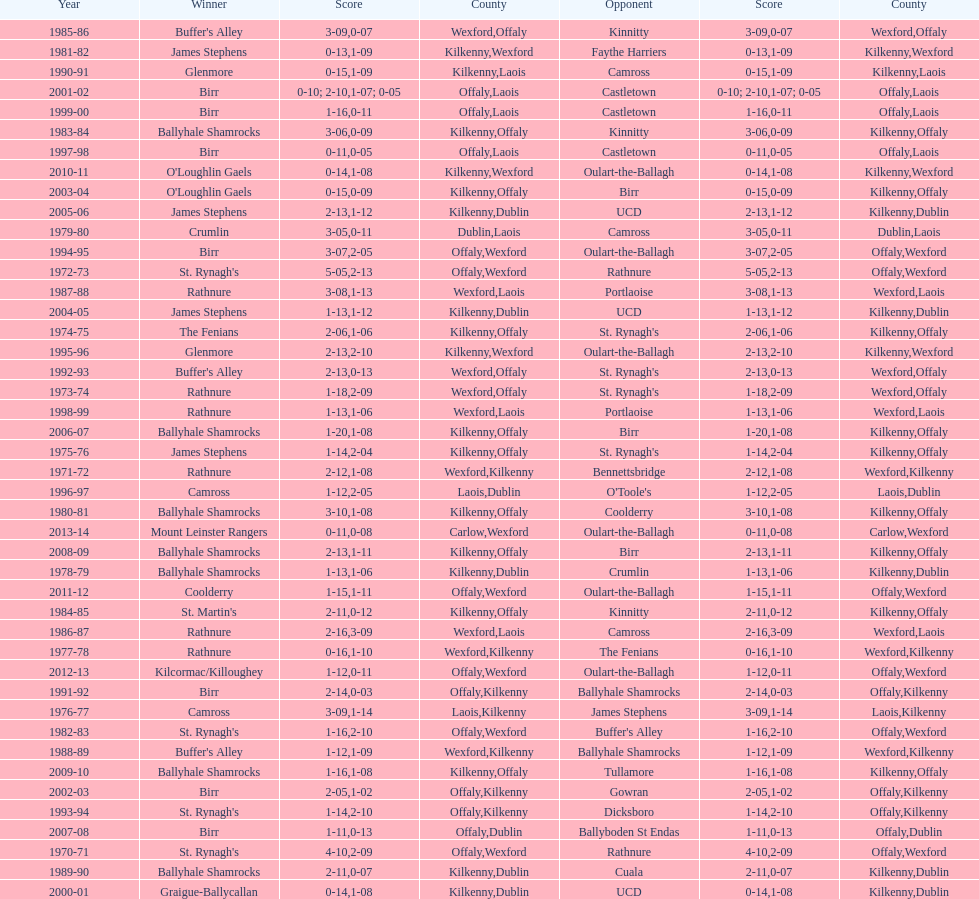Help me parse the entirety of this table. {'header': ['Year', 'Winner', 'Score', 'County', 'Opponent', 'Score', 'County'], 'rows': [['1985-86', "Buffer's Alley", '3-09', 'Wexford', 'Kinnitty', '0-07', 'Offaly'], ['1981-82', 'James Stephens', '0-13', 'Kilkenny', 'Faythe Harriers', '1-09', 'Wexford'], ['1990-91', 'Glenmore', '0-15', 'Kilkenny', 'Camross', '1-09', 'Laois'], ['2001-02', 'Birr', '0-10; 2-10', 'Offaly', 'Castletown', '1-07; 0-05', 'Laois'], ['1999-00', 'Birr', '1-16', 'Offaly', 'Castletown', '0-11', 'Laois'], ['1983-84', 'Ballyhale Shamrocks', '3-06', 'Kilkenny', 'Kinnitty', '0-09', 'Offaly'], ['1997-98', 'Birr', '0-11', 'Offaly', 'Castletown', '0-05', 'Laois'], ['2010-11', "O'Loughlin Gaels", '0-14', 'Kilkenny', 'Oulart-the-Ballagh', '1-08', 'Wexford'], ['2003-04', "O'Loughlin Gaels", '0-15', 'Kilkenny', 'Birr', '0-09', 'Offaly'], ['2005-06', 'James Stephens', '2-13', 'Kilkenny', 'UCD', '1-12', 'Dublin'], ['1979-80', 'Crumlin', '3-05', 'Dublin', 'Camross', '0-11', 'Laois'], ['1994-95', 'Birr', '3-07', 'Offaly', 'Oulart-the-Ballagh', '2-05', 'Wexford'], ['1972-73', "St. Rynagh's", '5-05', 'Offaly', 'Rathnure', '2-13', 'Wexford'], ['1987-88', 'Rathnure', '3-08', 'Wexford', 'Portlaoise', '1-13', 'Laois'], ['2004-05', 'James Stephens', '1-13', 'Kilkenny', 'UCD', '1-12', 'Dublin'], ['1974-75', 'The Fenians', '2-06', 'Kilkenny', "St. Rynagh's", '1-06', 'Offaly'], ['1995-96', 'Glenmore', '2-13', 'Kilkenny', 'Oulart-the-Ballagh', '2-10', 'Wexford'], ['1992-93', "Buffer's Alley", '2-13', 'Wexford', "St. Rynagh's", '0-13', 'Offaly'], ['1973-74', 'Rathnure', '1-18', 'Wexford', "St. Rynagh's", '2-09', 'Offaly'], ['1998-99', 'Rathnure', '1-13', 'Wexford', 'Portlaoise', '1-06', 'Laois'], ['2006-07', 'Ballyhale Shamrocks', '1-20', 'Kilkenny', 'Birr', '1-08', 'Offaly'], ['1975-76', 'James Stephens', '1-14', 'Kilkenny', "St. Rynagh's", '2-04', 'Offaly'], ['1971-72', 'Rathnure', '2-12', 'Wexford', 'Bennettsbridge', '1-08', 'Kilkenny'], ['1996-97', 'Camross', '1-12', 'Laois', "O'Toole's", '2-05', 'Dublin'], ['1980-81', 'Ballyhale Shamrocks', '3-10', 'Kilkenny', 'Coolderry', '1-08', 'Offaly'], ['2013-14', 'Mount Leinster Rangers', '0-11', 'Carlow', 'Oulart-the-Ballagh', '0-08', 'Wexford'], ['2008-09', 'Ballyhale Shamrocks', '2-13', 'Kilkenny', 'Birr', '1-11', 'Offaly'], ['1978-79', 'Ballyhale Shamrocks', '1-13', 'Kilkenny', 'Crumlin', '1-06', 'Dublin'], ['2011-12', 'Coolderry', '1-15', 'Offaly', 'Oulart-the-Ballagh', '1-11', 'Wexford'], ['1984-85', "St. Martin's", '2-11', 'Kilkenny', 'Kinnitty', '0-12', 'Offaly'], ['1986-87', 'Rathnure', '2-16', 'Wexford', 'Camross', '3-09', 'Laois'], ['1977-78', 'Rathnure', '0-16', 'Wexford', 'The Fenians', '1-10', 'Kilkenny'], ['2012-13', 'Kilcormac/Killoughey', '1-12', 'Offaly', 'Oulart-the-Ballagh', '0-11', 'Wexford'], ['1991-92', 'Birr', '2-14', 'Offaly', 'Ballyhale Shamrocks', '0-03', 'Kilkenny'], ['1976-77', 'Camross', '3-09', 'Laois', 'James Stephens', '1-14', 'Kilkenny'], ['1982-83', "St. Rynagh's", '1-16', 'Offaly', "Buffer's Alley", '2-10', 'Wexford'], ['1988-89', "Buffer's Alley", '1-12', 'Wexford', 'Ballyhale Shamrocks', '1-09', 'Kilkenny'], ['2009-10', 'Ballyhale Shamrocks', '1-16', 'Kilkenny', 'Tullamore', '1-08', 'Offaly'], ['2002-03', 'Birr', '2-05', 'Offaly', 'Gowran', '1-02', 'Kilkenny'], ['1993-94', "St. Rynagh's", '1-14', 'Offaly', 'Dicksboro', '2-10', 'Kilkenny'], ['2007-08', 'Birr', '1-11', 'Offaly', 'Ballyboden St Endas', '0-13', 'Dublin'], ['1970-71', "St. Rynagh's", '4-10', 'Offaly', 'Rathnure', '2-09', 'Wexford'], ['1989-90', 'Ballyhale Shamrocks', '2-11', 'Kilkenny', 'Cuala', '0-07', 'Dublin'], ['2000-01', 'Graigue-Ballycallan', '0-14', 'Kilkenny', 'UCD', '1-08', 'Dublin']]} What was the last season the leinster senior club hurling championships was won by a score differential of less than 11? 2007-08. 